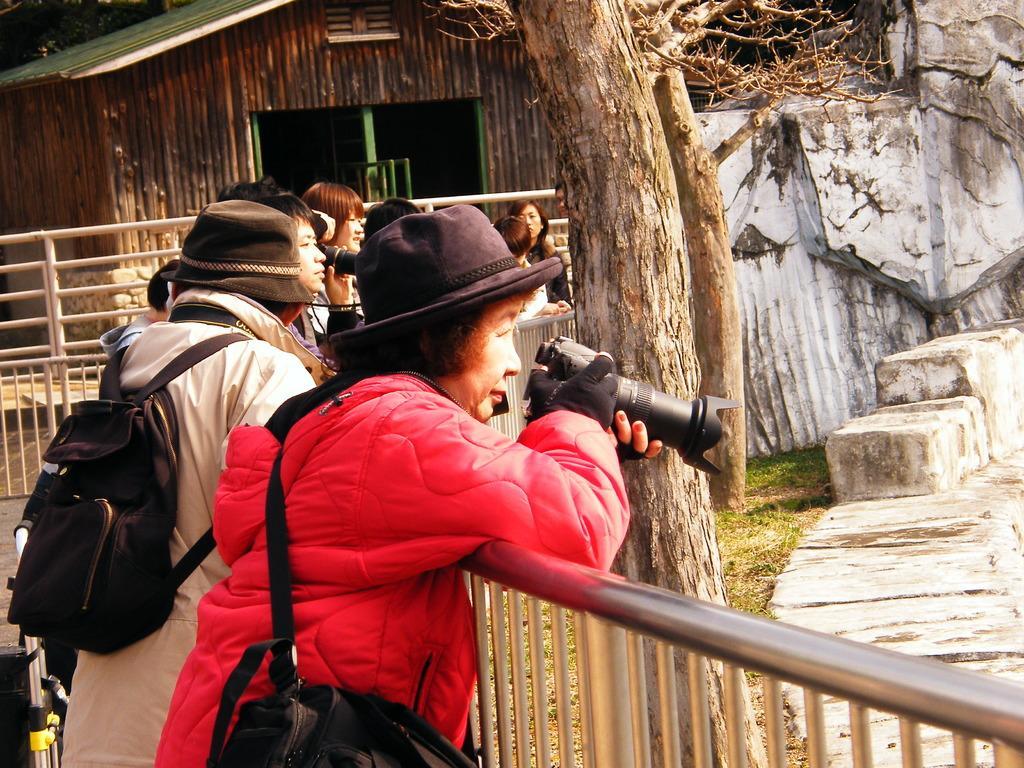Could you give a brief overview of what you see in this image? In this image there are people leaning on a railing and taking pictures with cameras, in the background there are trees, rocks, the house and a railing. 